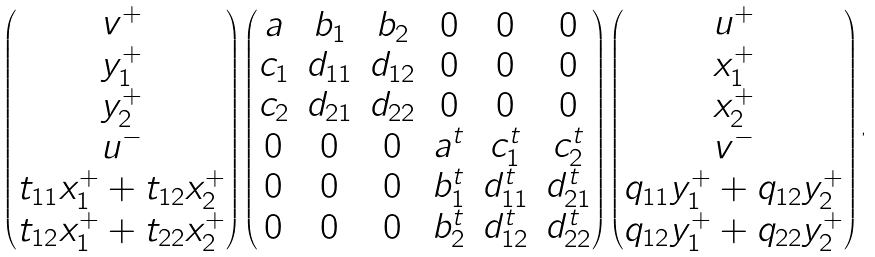<formula> <loc_0><loc_0><loc_500><loc_500>\begin{pmatrix} v ^ { + } \\ y ^ { + } _ { 1 } \\ y ^ { + } _ { 2 } \\ u ^ { - } \\ t _ { 1 1 } x ^ { + } _ { 1 } + t _ { 1 2 } x ^ { + } _ { 2 } \\ t _ { 1 2 } x ^ { + } _ { 1 } + t _ { 2 2 } x ^ { + } _ { 2 } \end{pmatrix} \begin{pmatrix} a & b _ { 1 } & b _ { 2 } & 0 & 0 & 0 \\ c _ { 1 } & d _ { 1 1 } & d _ { 1 2 } & 0 & 0 & 0 \\ c _ { 2 } & d _ { 2 1 } & d _ { 2 2 } & 0 & 0 & 0 \\ 0 & 0 & 0 & a ^ { t } & c ^ { t } _ { 1 } & c ^ { t } _ { 2 } \\ 0 & 0 & 0 & b ^ { t } _ { 1 } & d ^ { t } _ { 1 1 } & d ^ { t } _ { 2 1 } \\ 0 & 0 & 0 & b ^ { t } _ { 2 } & d ^ { t } _ { 1 2 } & d ^ { t } _ { 2 2 } \\ \end{pmatrix} \begin{pmatrix} u ^ { + } \\ x ^ { + } _ { 1 } \\ x ^ { + } _ { 2 } \\ v ^ { - } \\ q _ { 1 1 } y ^ { + } _ { 1 } + q _ { 1 2 } y ^ { + } _ { 2 } \\ q _ { 1 2 } y ^ { + } _ { 1 } + q _ { 2 2 } y ^ { + } _ { 2 } \end{pmatrix} ,</formula> 